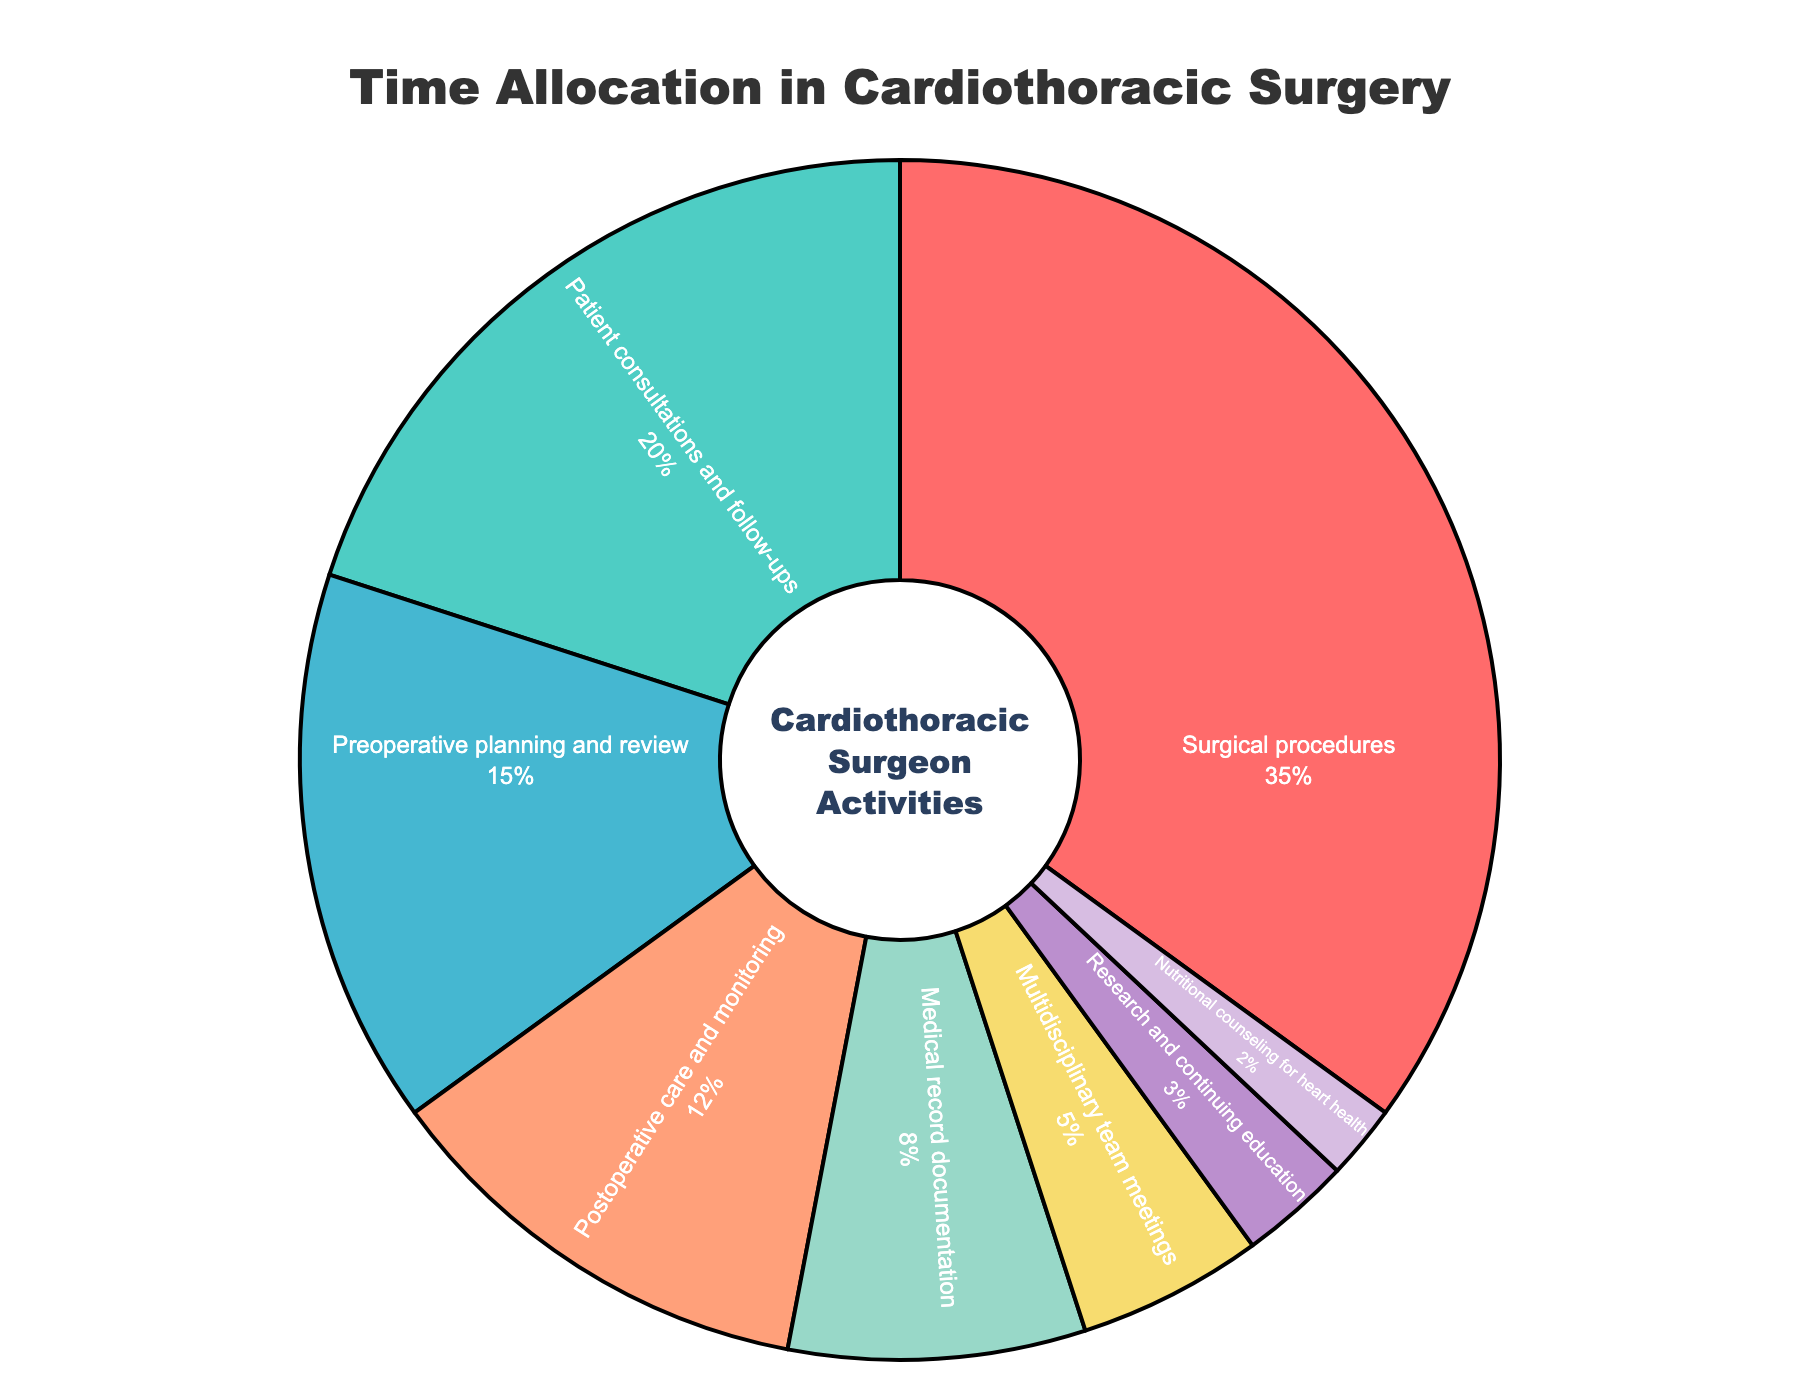What activity takes up the most time for cardiothoracic surgeons? The activity with the largest percentage in the pie chart is "Surgical procedures" with 35%. Just look for the segment with the highest value.
Answer: Surgical procedures How much more time is spent on surgical procedures compared to patient consultations and follow-ups? The percentage for surgical procedures is 35%, and for patient consultations and follow-ups, it is 20%. Subtract the smaller percentage from the larger one: 35% - 20% = 15%.
Answer: 15% Which three activities take up the least amount of time? Look for the three smallest segments in the pie chart. These are "Nutritional counseling for heart health" at 2%, "Research and continuing education" at 3%, and "Multidisciplinary team meetings" at 5%.
Answer: Nutritional counseling for heart health, Research and continuing education, Multidisciplinary team meetings What is the combined percentage of time spent on preoperative planning and review and postoperative care and monitoring? Add the percentages for preoperative planning and review (15%) and postoperative care and monitoring (12%): 15% + 12% = 27%.
Answer: 27% Is more time spent on medical record documentation or multidisciplinary team meetings? Compare the percentages for medical record documentation (8%) and multidisciplinary team meetings (5%). Since 8% is greater than 5%, more time is spent on medical record documentation.
Answer: Medical record documentation Which activity is represented by the red color in the pie chart? Identify the red segment by comparing the legend colors with the chart. The red segment corresponds to "Surgical procedures" at 35%.
Answer: Surgical procedures What is the average percentage of time spent on research and continuing education, and nutritional counseling for heart health? Add the percentages for research and continuing education (3%) and nutritional counseling for heart health (2%) and then divide by 2: (3% + 2%) / 2 = 2.5%.
Answer: 2.5% By how much does the percentage of time spent on patient consultations and follow-ups exceed the percentage spent on medical record documentation? Subtract the percentage for medical record documentation (8%) from the percentage for patient consultations and follow-ups (20%): 20% - 8% = 12%.
Answer: 12% Which activity uses a green color in the pie chart? Identify the green segment by comparing the legend colors with the chart. The green segment corresponds to "Patient consultations and follow-ups" at 20%.
Answer: Patient consultations and follow-ups 